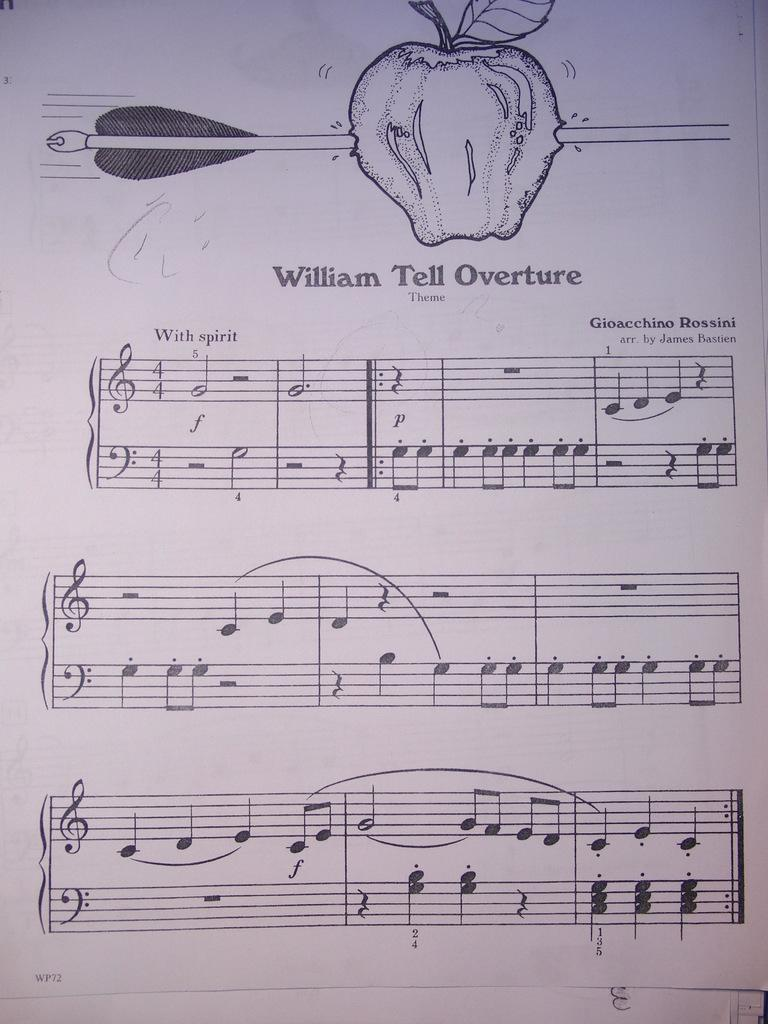What is depicted on the paper in the image? The paper contains a diagram of an apple. What additional feature is included in the diagram of the apple? The diagram of an apple includes an arrow. What other elements can be seen in the image besides the paper? There are text and music symbols in the image. How many donkeys are visible in the image? There are no donkeys present in the image. What type of wood is used to create the diagram of the apple? The image does not provide information about the material used to create the diagram of the apple. 